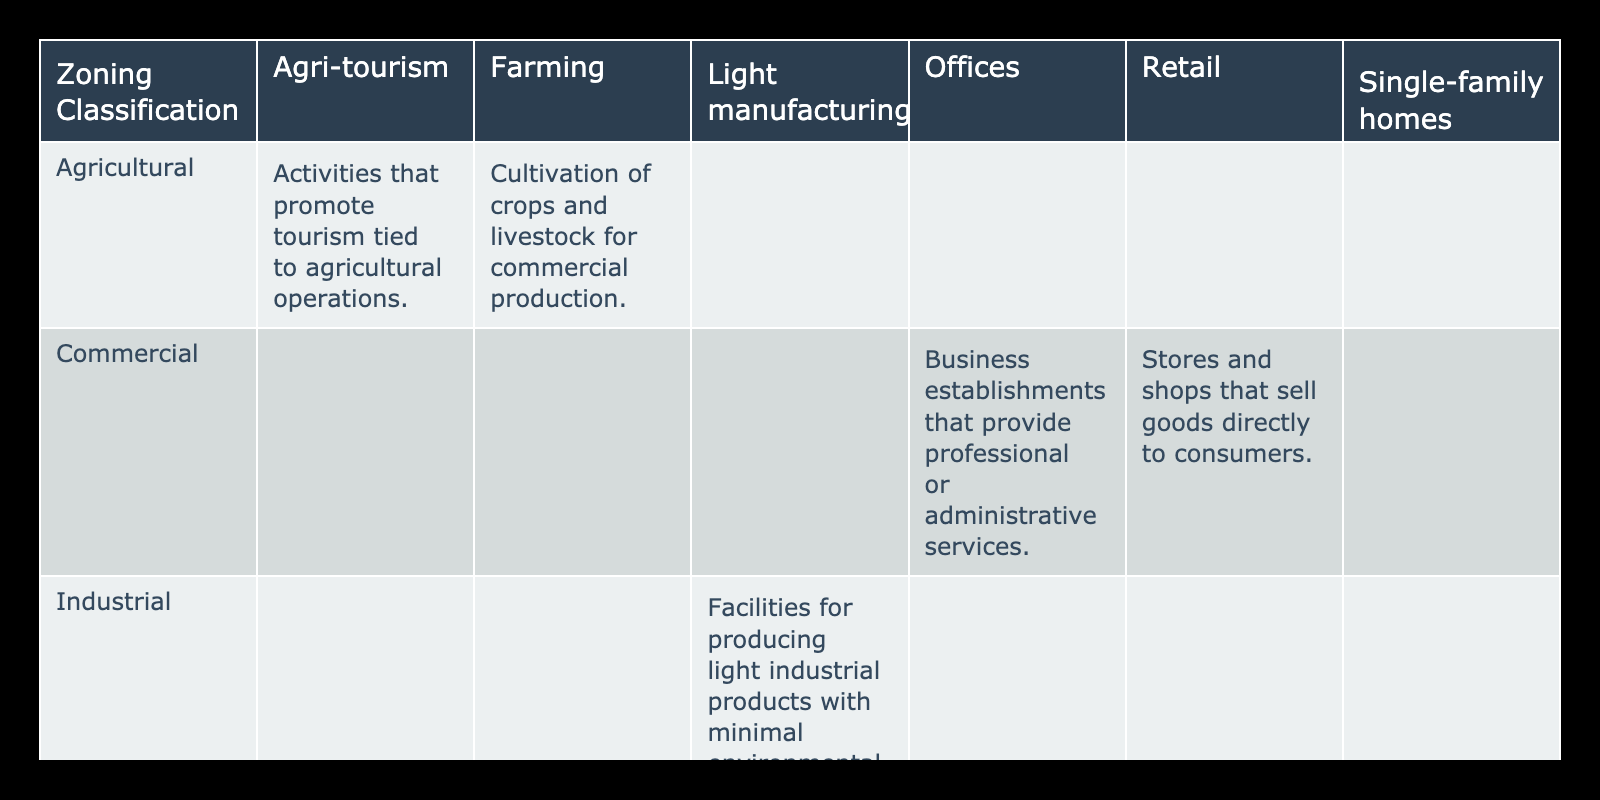What types of activities are allowed in residential zoning? According to the table, the allowed activities in residential zoning include single-family homes. This is explicitly mentioned under the allowed activities for the residential zoning classification.
Answer: Single-family homes Is farming allowed in commercial zoning? The table indicates that farming is categorized under agricultural zoning classifications, not commercial. Therefore, farming activities are not allowed in commercial zones.
Answer: No What is the description of light manufacturing activities? In the table, light manufacturing is listed under industrial zoning, and its description states that these are facilities for producing light industrial products with minimal environmental impact.
Answer: Facilities for producing light industrial products with minimal environmental impact How many allowed activities are listed under agricultural zoning? The table shows two allowed activities under agricultural zoning: farming and agri-tourism. Thus, the total count of allowed activities for agricultural zoning is two.
Answer: 2 Are retail activities permitted in agricultural zoning? Looking at the table, retail is classified under commercial zoning, and agricultural zoning does not include retail activities in its allowed activities. Therefore, retail activities are not permitted in agricultural zoning.
Answer: No What is the total number of unique zoning classifications in the table? The table presents five unique zoning classifications: residential, commercial, industrial, agricultural. This means there are four distinct zones listed, regardless of the allowed activities under each.
Answer: 4 What is the description for stores and shops that sell goods directly to consumers? The table clearly states that the description for retail activities, which includes stores and shops selling goods directly to consumers, is exactly that. Therefore, the description is stores and shops that sell goods directly to consumers.
Answer: Stores and shops that sell goods directly to consumers Which zoning classification allows for both farming and agri-tourism activities? According to the table, both farming and agri-tourism are allowed activities specifically under the agricultural zoning classification, indicating that no other zoning classification permits these activities.
Answer: Agricultural What is the difference in allowed activities between industrial and commercial zoning? From the table, industrial zoning allows for light manufacturing, while commercial zoning permits offices and retail activities. Therefore, the difference lies in the type of activities focused on production versus business services and retail.
Answer: Light manufacturing vs. offices and retail 